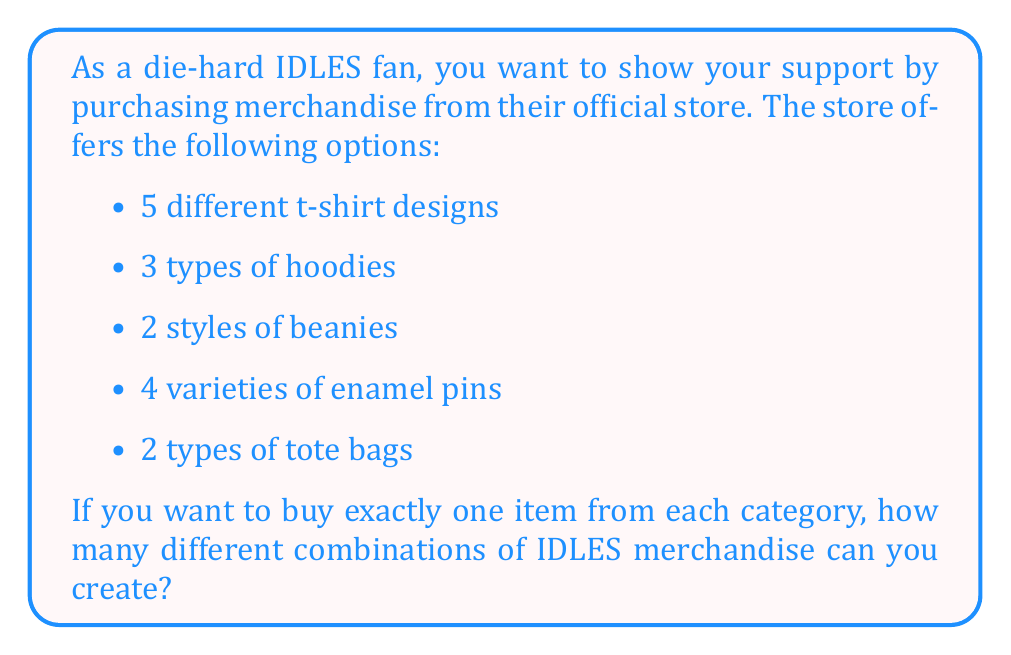Could you help me with this problem? To solve this problem, we'll use the multiplication principle of counting. This principle states that if we have a sequence of independent choices, the total number of possible outcomes is the product of the number of possibilities for each choice.

Let's break down the choices:
1. T-shirts: 5 options
2. Hoodies: 3 options
3. Beanies: 2 options
4. Enamel pins: 4 options
5. Tote bags: 2 options

For each combination, we choose one item from each category. The choices are independent, meaning the selection of one item doesn't affect the options for the other categories.

Therefore, we multiply the number of options for each category:

$$ \text{Total combinations} = 5 \times 3 \times 2 \times 4 \times 2 $$

Calculating this:
$$ 5 \times 3 = 15 $$
$$ 15 \times 2 = 30 $$
$$ 30 \times 4 = 120 $$
$$ 120 \times 2 = 240 $$

Thus, there are 240 possible combinations of IDLES merchandise when selecting one item from each category.
Answer: 240 combinations 